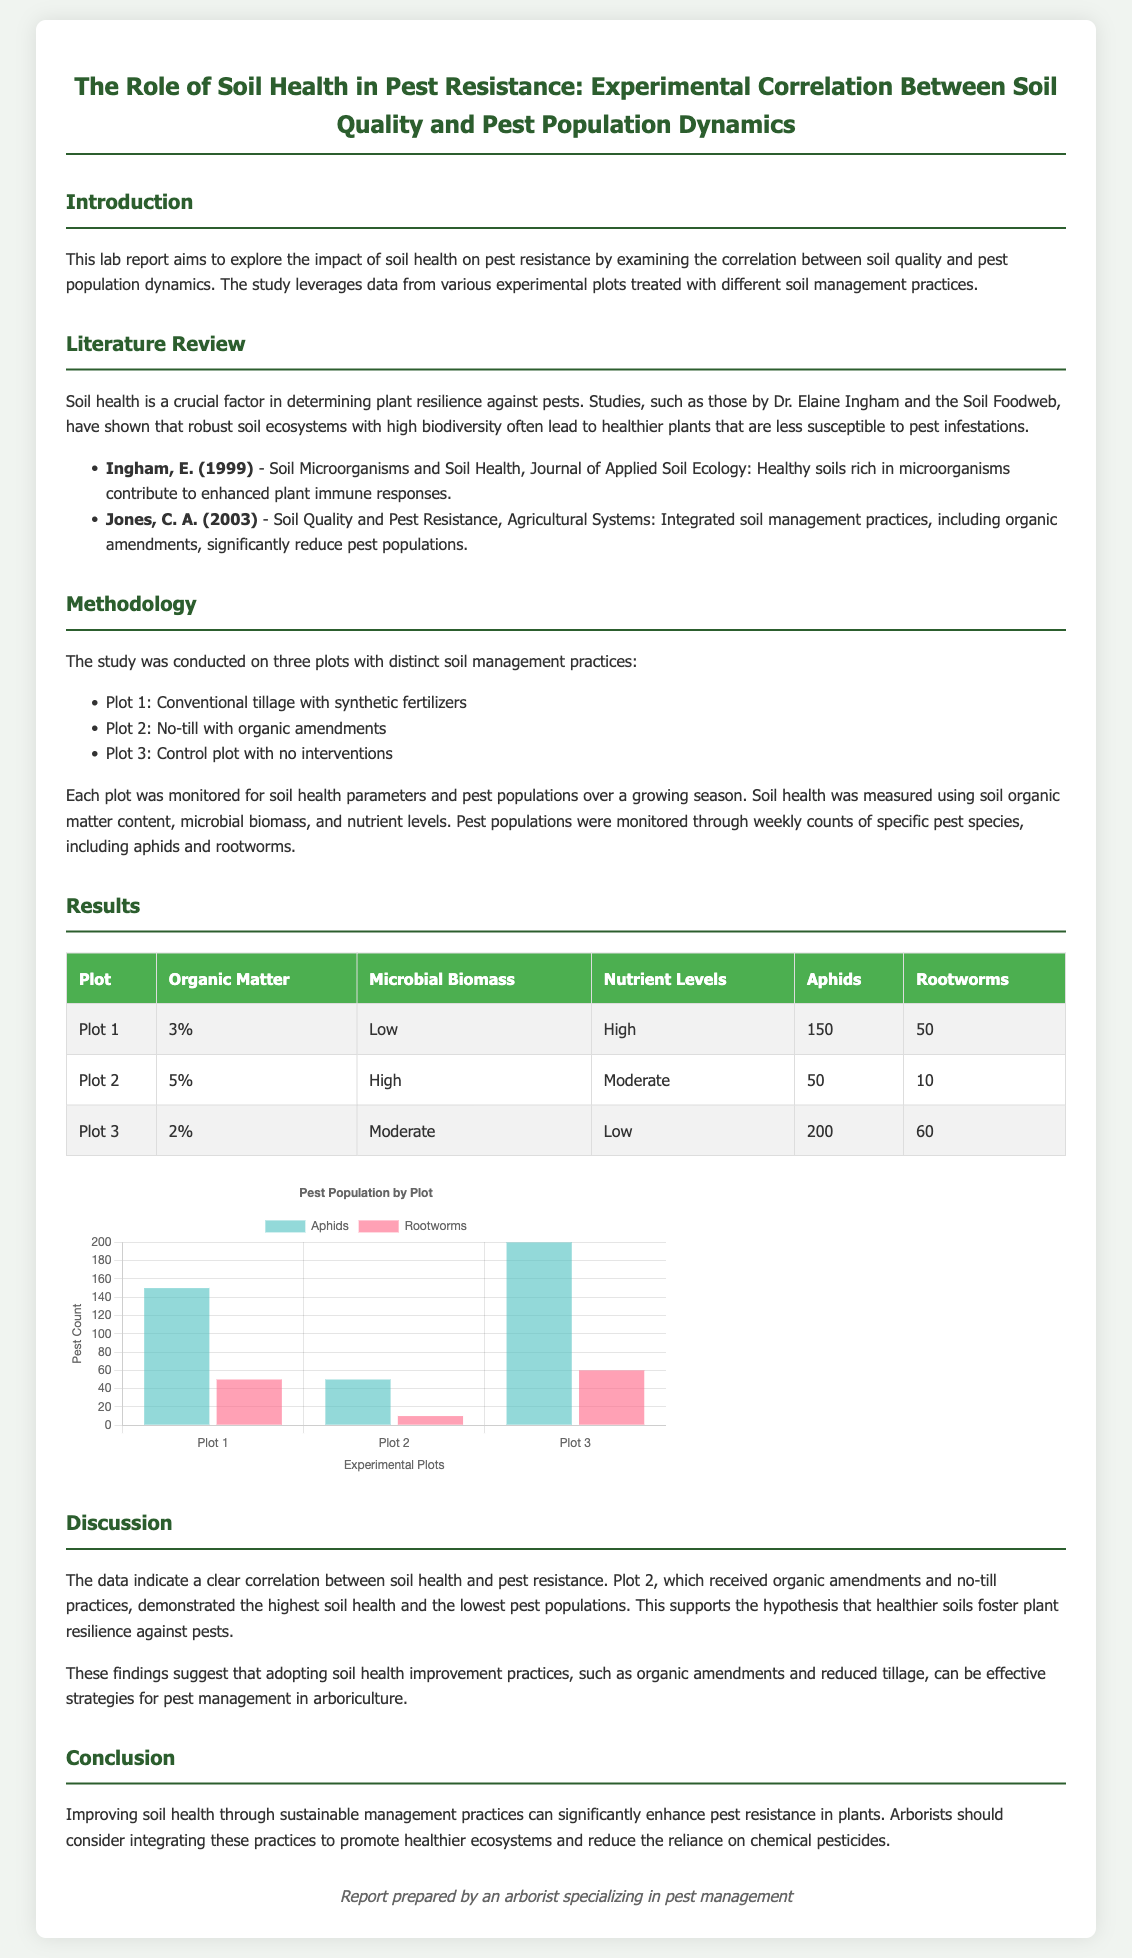What is the purpose of the lab report? The purpose of the lab report is to explore the impact of soil health on pest resistance by examining the correlation between soil quality and pest population dynamics.
Answer: Explore the impact of soil health on pest resistance Who conducted the literature review mentioned in the document? The literature review includes references from Dr. Elaine Ingham and C. A. Jones, indicating their contributions to the study of soil health and pest resistance.
Answer: Dr. Elaine Ingham and C. A. Jones What are the three types of plots used in the study? The types of plots are Conventional tillage with synthetic fertilizers, No-till with organic amendments, and Control plot with no interventions.
Answer: Conventional tillage, No-till, Control plot Which plot showed the highest organic matter content? The table in the results indicates that Plot 2 has an organic matter content of 5%, which is the highest among the three plots.
Answer: Plot 2 What was the aphid count in Plot 1? According to the results table, the aphid count in Plot 1 is 150.
Answer: 150 How does soil health influence pest populations based on the results? The results discussion notes that healthier soils foster plant resilience against pests, with Plot 2 showing the lowest pest populations.
Answer: Healthier soils foster resilience What is the conclusion drawn from the study? The conclusion of the study emphasizes that improving soil health can significantly enhance pest resistance, benefiting pest management in arboriculture.
Answer: Improve soil health to enhance pest resistance What is the significance of using organic amendments according to the findings? The findings suggest that organic amendments contribute to higher soil health and lower pest populations, making them significant for pest management strategies.
Answer: Higher soil health and lower pest populations What type of chart is used to present the pest population data? The document features a bar chart to visually represent the pest population by plot.
Answer: Bar chart 